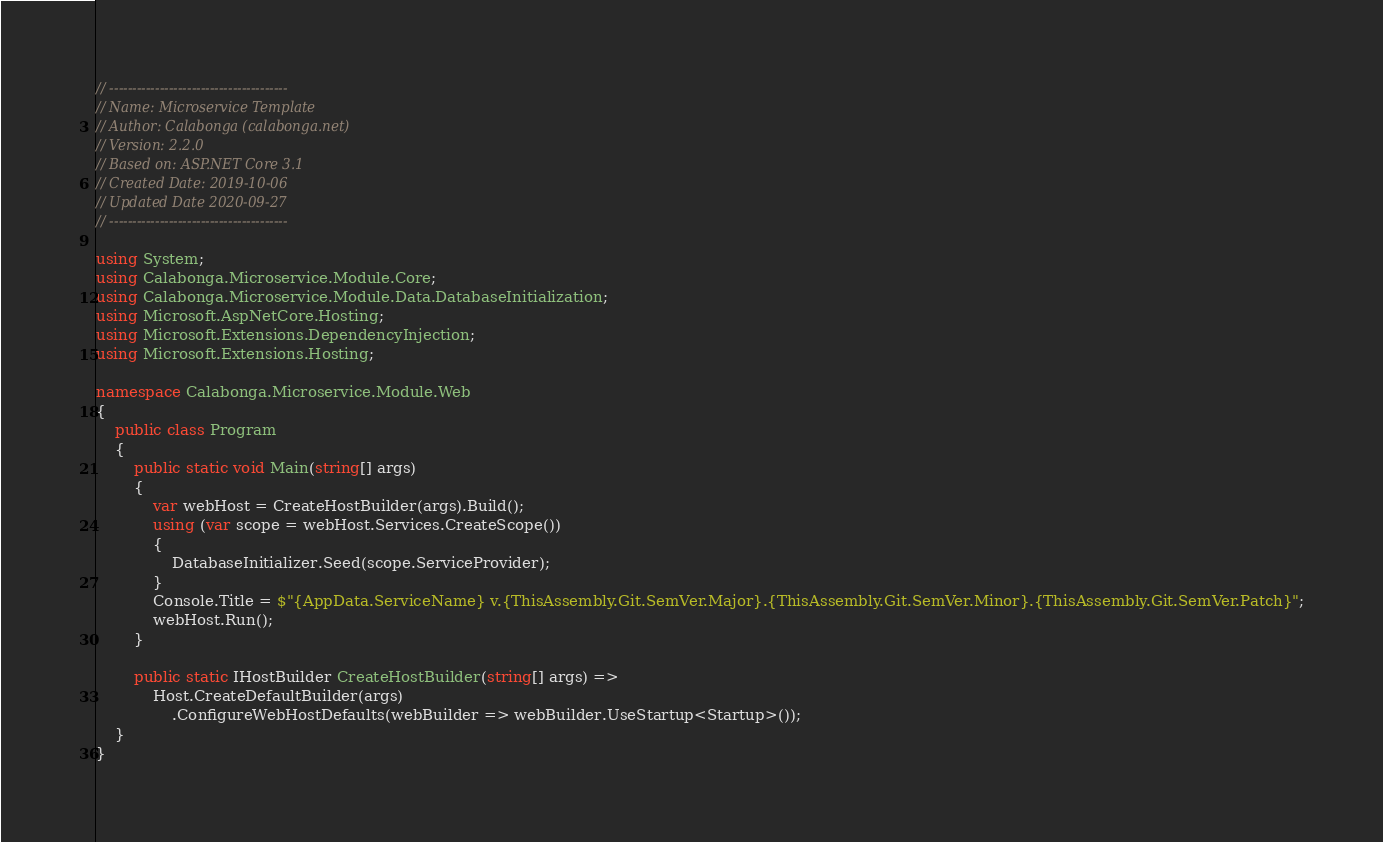Convert code to text. <code><loc_0><loc_0><loc_500><loc_500><_C#_>// ---------------------------------------
// Name: Microservice Template
// Author: Calabonga (calabonga.net)
// Version: 2.2.0
// Based on: ASP.NET Core 3.1
// Created Date: 2019-10-06
// Updated Date 2020-09-27
// ---------------------------------------

using System;
using Calabonga.Microservice.Module.Core;
using Calabonga.Microservice.Module.Data.DatabaseInitialization;
using Microsoft.AspNetCore.Hosting;
using Microsoft.Extensions.DependencyInjection;
using Microsoft.Extensions.Hosting;

namespace Calabonga.Microservice.Module.Web
{
    public class Program
    {
        public static void Main(string[] args)
        {
            var webHost = CreateHostBuilder(args).Build();
            using (var scope = webHost.Services.CreateScope())
            {
                DatabaseInitializer.Seed(scope.ServiceProvider);
            }
            Console.Title = $"{AppData.ServiceName} v.{ThisAssembly.Git.SemVer.Major}.{ThisAssembly.Git.SemVer.Minor}.{ThisAssembly.Git.SemVer.Patch}";
            webHost.Run();
        }

        public static IHostBuilder CreateHostBuilder(string[] args) =>
            Host.CreateDefaultBuilder(args)
                .ConfigureWebHostDefaults(webBuilder => webBuilder.UseStartup<Startup>());
    }
}
</code> 